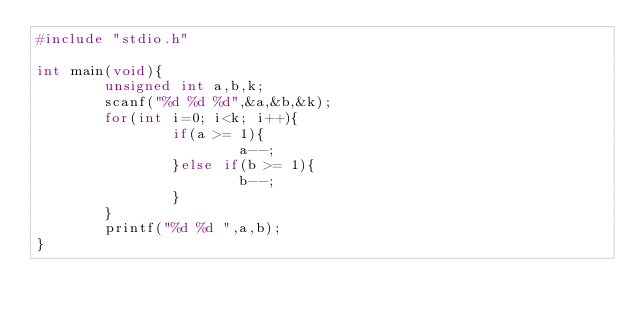<code> <loc_0><loc_0><loc_500><loc_500><_C_>#include "stdio.h"

int main(void){
        unsigned int a,b,k;
        scanf("%d %d %d",&a,&b,&k);
        for(int i=0; i<k; i++){
                if(a >= 1){
                        a--;
                }else if(b >= 1){
                        b--;
                }
        }
        printf("%d %d ",a,b);
}
</code> 